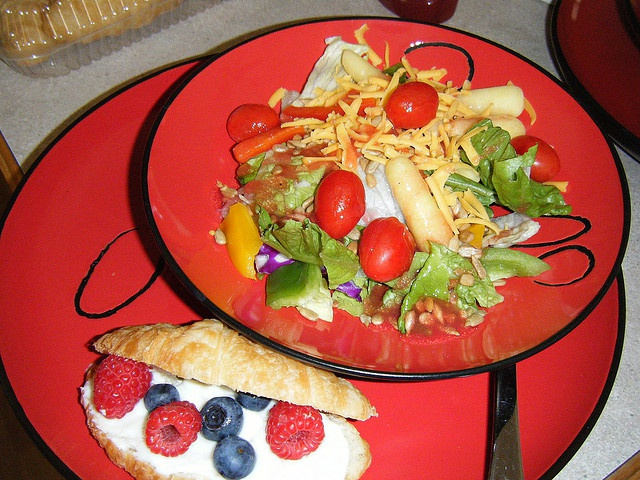Describe the objects in this image and their specific colors. I can see bowl in gray, red, brown, and khaki tones, sandwich in gray, ivory, khaki, tan, and salmon tones, dining table in gray, darkgray, and black tones, spoon in gray, black, maroon, red, and darkgreen tones, and carrot in gray, red, brown, and tan tones in this image. 